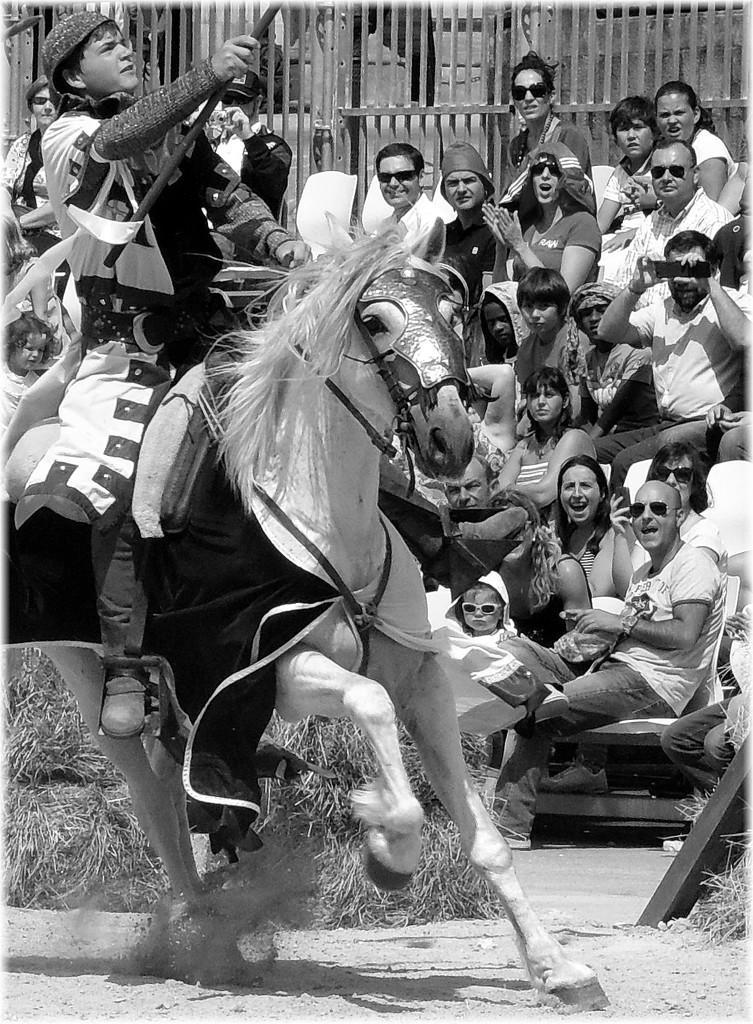How would you summarize this image in a sentence or two? The person sitting on a horse is holding a rod and there are audience sitting beside him. 